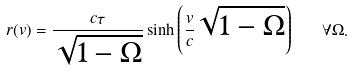Convert formula to latex. <formula><loc_0><loc_0><loc_500><loc_500>r ( v ) = \frac { c \tau } { \sqrt { 1 - \Omega } } \sinh \left ( \frac { v } { c } \sqrt { 1 - \Omega } \right ) \quad \forall \Omega .</formula> 